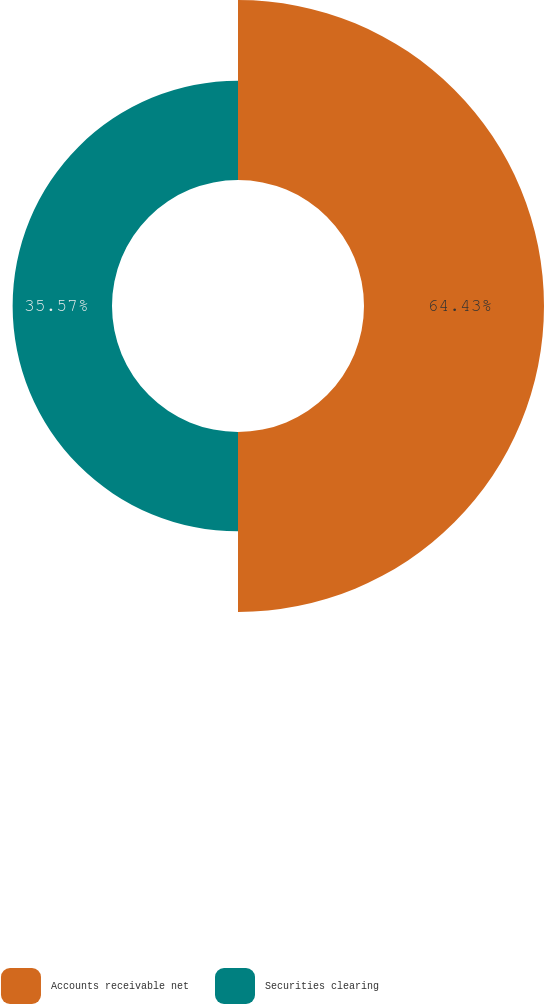Convert chart to OTSL. <chart><loc_0><loc_0><loc_500><loc_500><pie_chart><fcel>Accounts receivable net<fcel>Securities clearing<nl><fcel>64.43%<fcel>35.57%<nl></chart> 